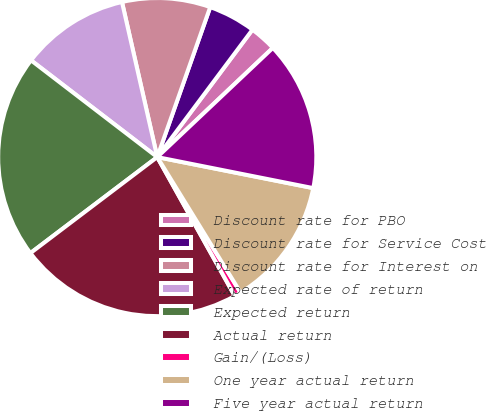Convert chart. <chart><loc_0><loc_0><loc_500><loc_500><pie_chart><fcel>Discount rate for PBO<fcel>Discount rate for Service Cost<fcel>Discount rate for Interest on<fcel>Expected rate of return<fcel>Expected return<fcel>Actual return<fcel>Gain/(Loss)<fcel>One year actual return<fcel>Five year actual return<nl><fcel>2.74%<fcel>4.81%<fcel>8.96%<fcel>11.03%<fcel>20.72%<fcel>22.79%<fcel>0.67%<fcel>13.1%<fcel>15.17%<nl></chart> 